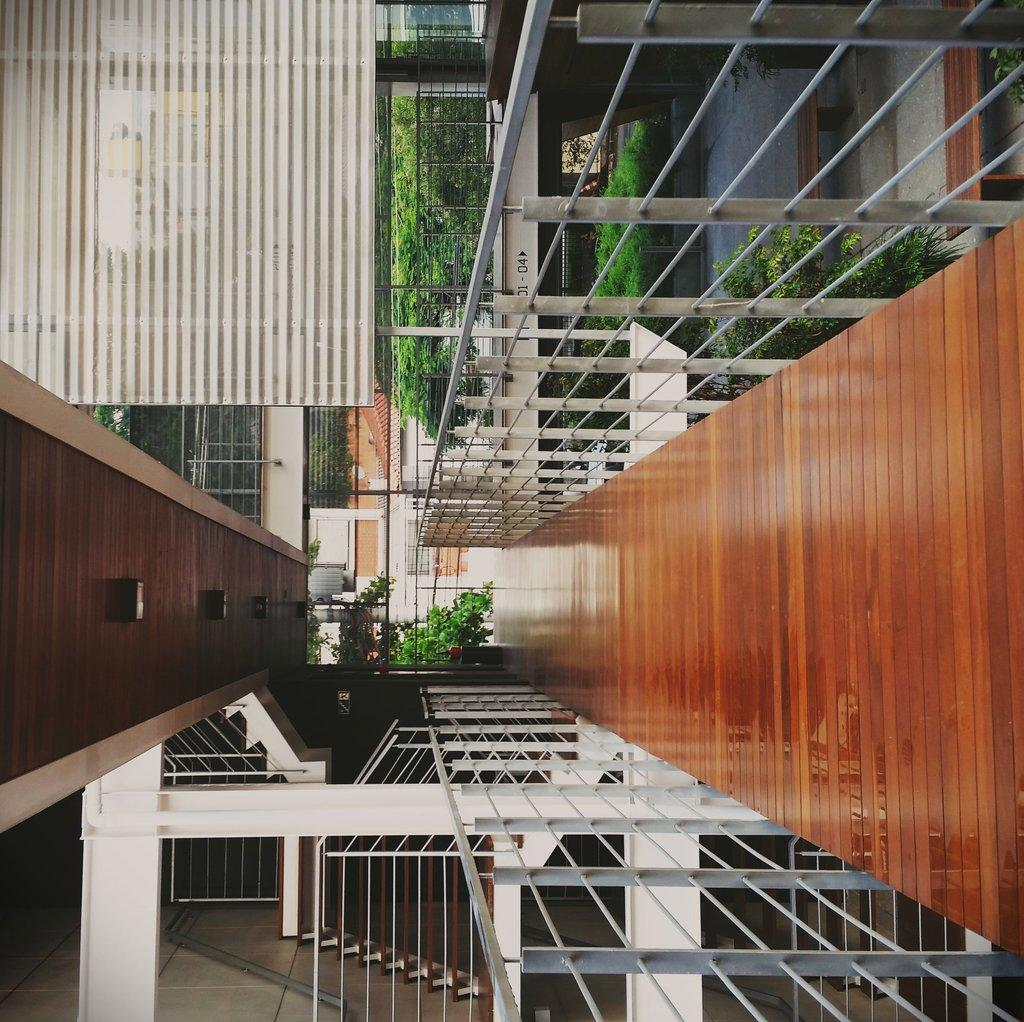What structure is the main subject of the image? There is a bridge in the image. What feature does the bridge have? The bridge has fencing. What type of vegetation can be seen in the image? There are plants visible in the image. What objects are related to cooking in the image? There are grills in the image. How many pizzas are being served on the bridge in the image? There are no pizzas present in the image; it features a bridge with fencing and plants. What type of crime is being committed on the bridge in the image? There is no crime being committed in the image; it is a peaceful scene with a bridge, fencing, plants, and grills. 